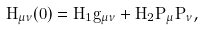Convert formula to latex. <formula><loc_0><loc_0><loc_500><loc_500>H _ { \mu \nu } ( 0 ) = H _ { 1 } \tilde { g } _ { \mu \nu } + H _ { 2 } P _ { \mu } P _ { \nu } ,</formula> 